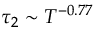<formula> <loc_0><loc_0><loc_500><loc_500>\tau _ { 2 } \sim T ^ { - 0 . 7 7 }</formula> 